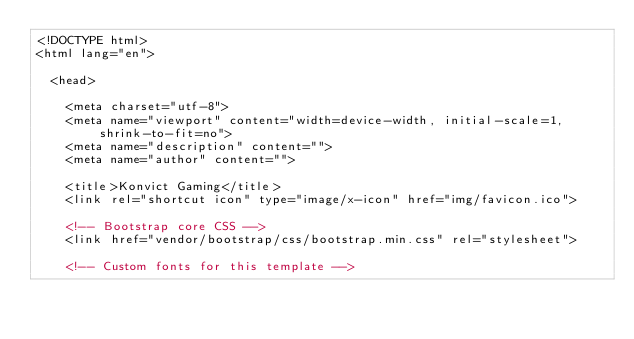<code> <loc_0><loc_0><loc_500><loc_500><_HTML_><!DOCTYPE html>
<html lang="en">

  <head>

    <meta charset="utf-8">
    <meta name="viewport" content="width=device-width, initial-scale=1, shrink-to-fit=no">
    <meta name="description" content="">
    <meta name="author" content="">

    <title>Konvict Gaming</title>
    <link rel="shortcut icon" type="image/x-icon" href="img/favicon.ico">

    <!-- Bootstrap core CSS -->
    <link href="vendor/bootstrap/css/bootstrap.min.css" rel="stylesheet">

    <!-- Custom fonts for this template --></code> 